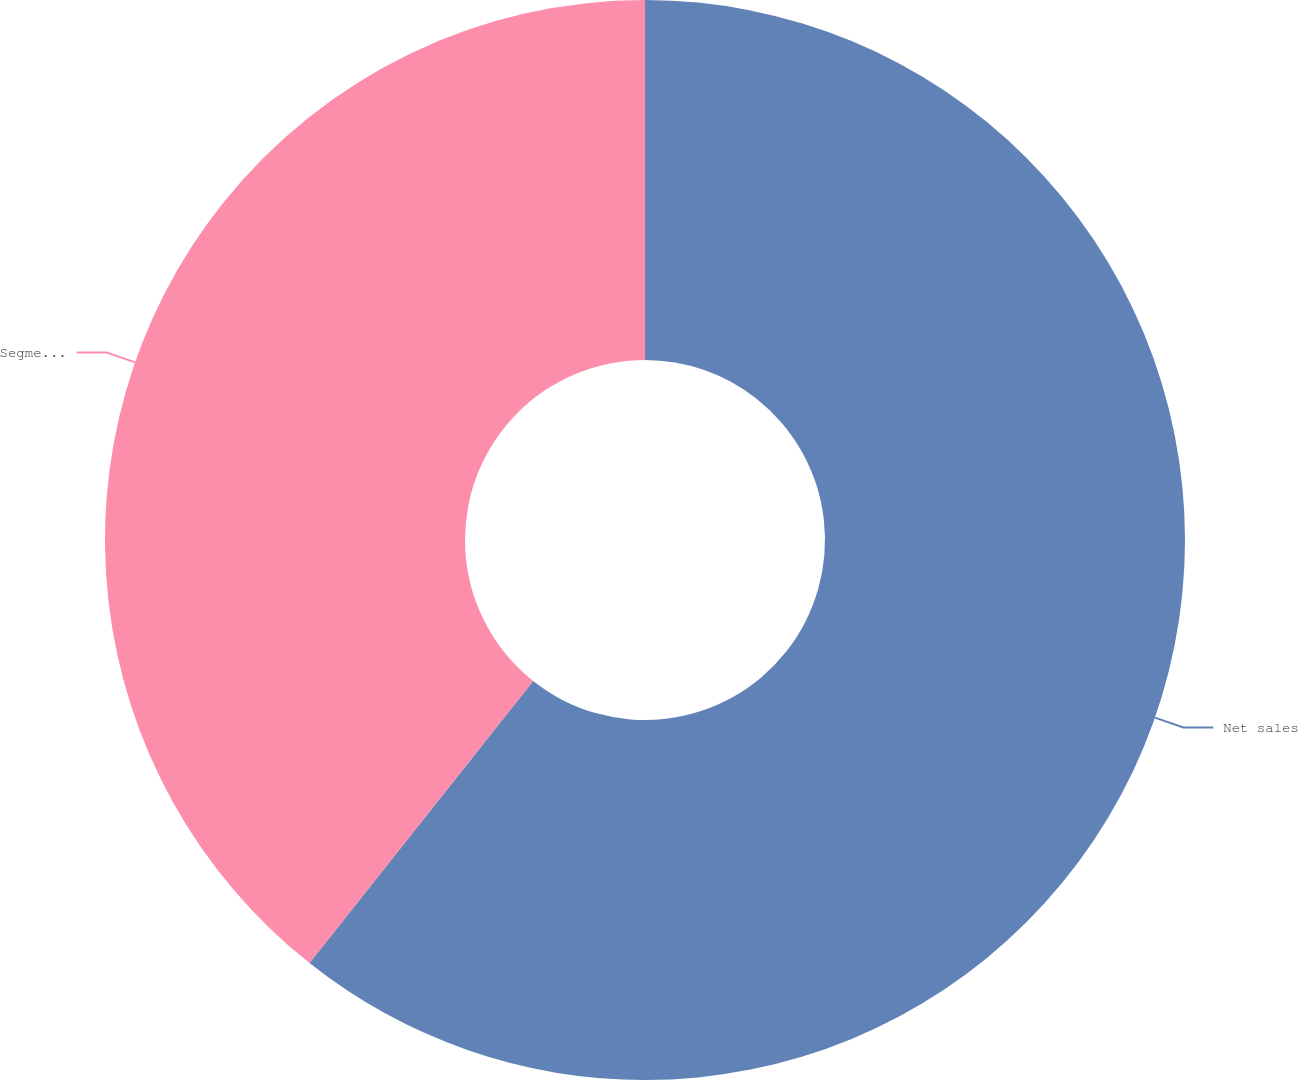Convert chart to OTSL. <chart><loc_0><loc_0><loc_500><loc_500><pie_chart><fcel>Net sales<fcel>Segment income<nl><fcel>60.67%<fcel>39.33%<nl></chart> 